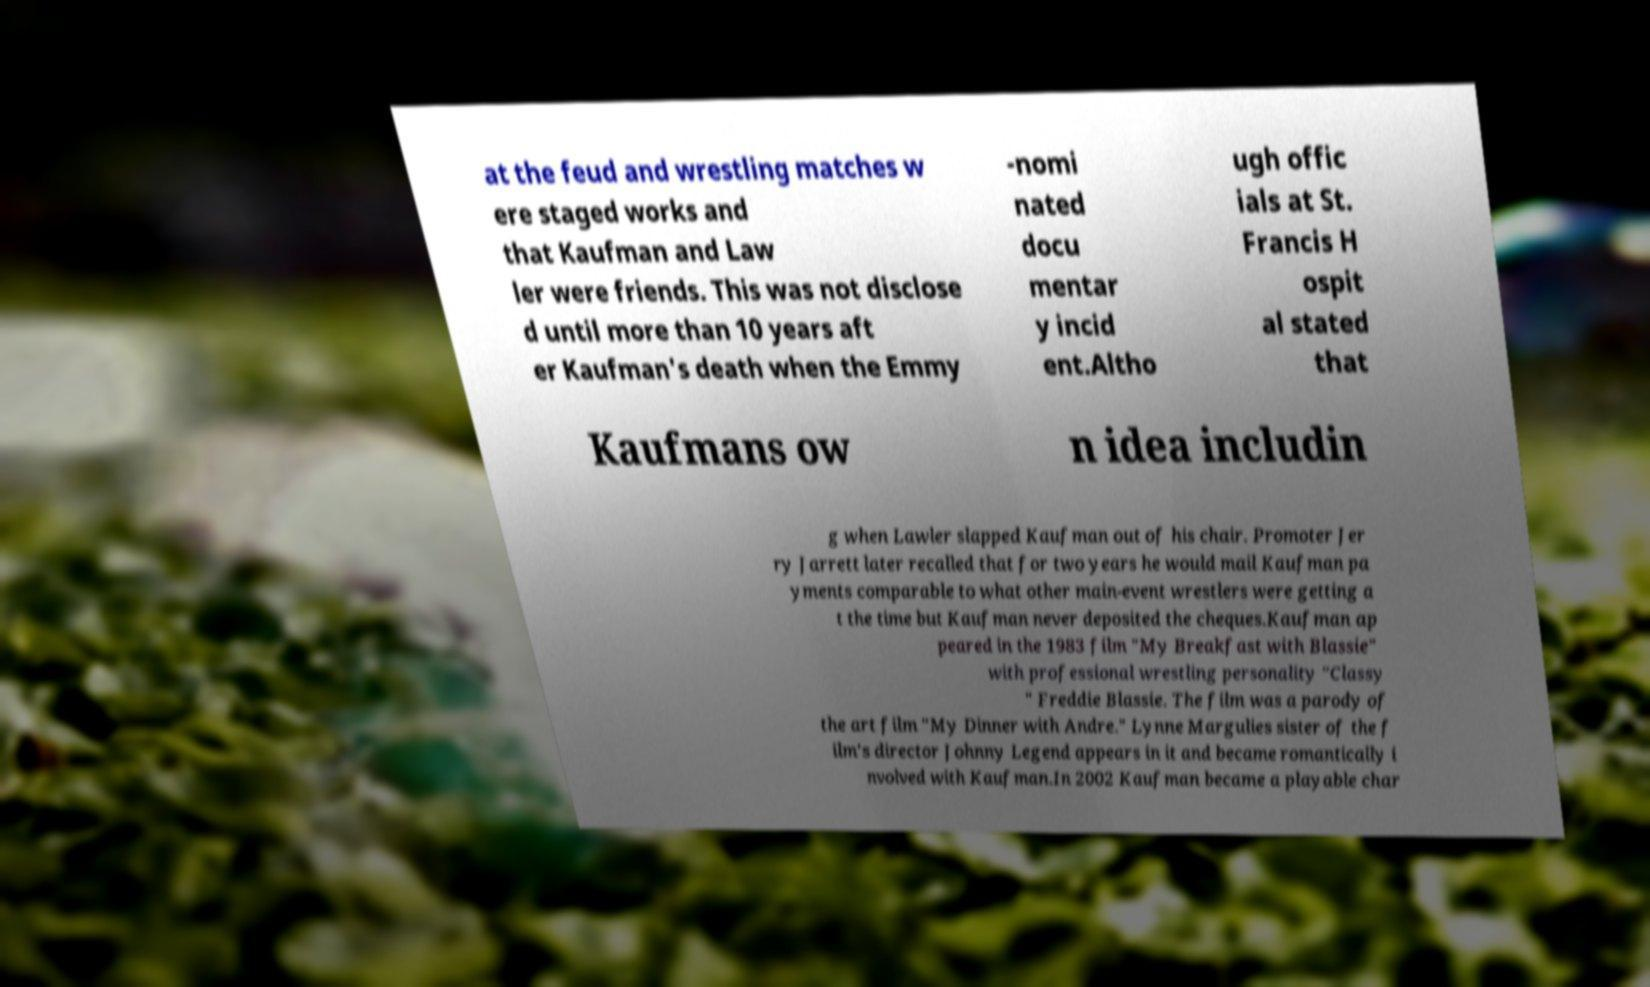Please identify and transcribe the text found in this image. at the feud and wrestling matches w ere staged works and that Kaufman and Law ler were friends. This was not disclose d until more than 10 years aft er Kaufman's death when the Emmy -nomi nated docu mentar y incid ent.Altho ugh offic ials at St. Francis H ospit al stated that Kaufmans ow n idea includin g when Lawler slapped Kaufman out of his chair. Promoter Jer ry Jarrett later recalled that for two years he would mail Kaufman pa yments comparable to what other main-event wrestlers were getting a t the time but Kaufman never deposited the cheques.Kaufman ap peared in the 1983 film "My Breakfast with Blassie" with professional wrestling personality "Classy " Freddie Blassie. The film was a parody of the art film "My Dinner with Andre." Lynne Margulies sister of the f ilm's director Johnny Legend appears in it and became romantically i nvolved with Kaufman.In 2002 Kaufman became a playable char 